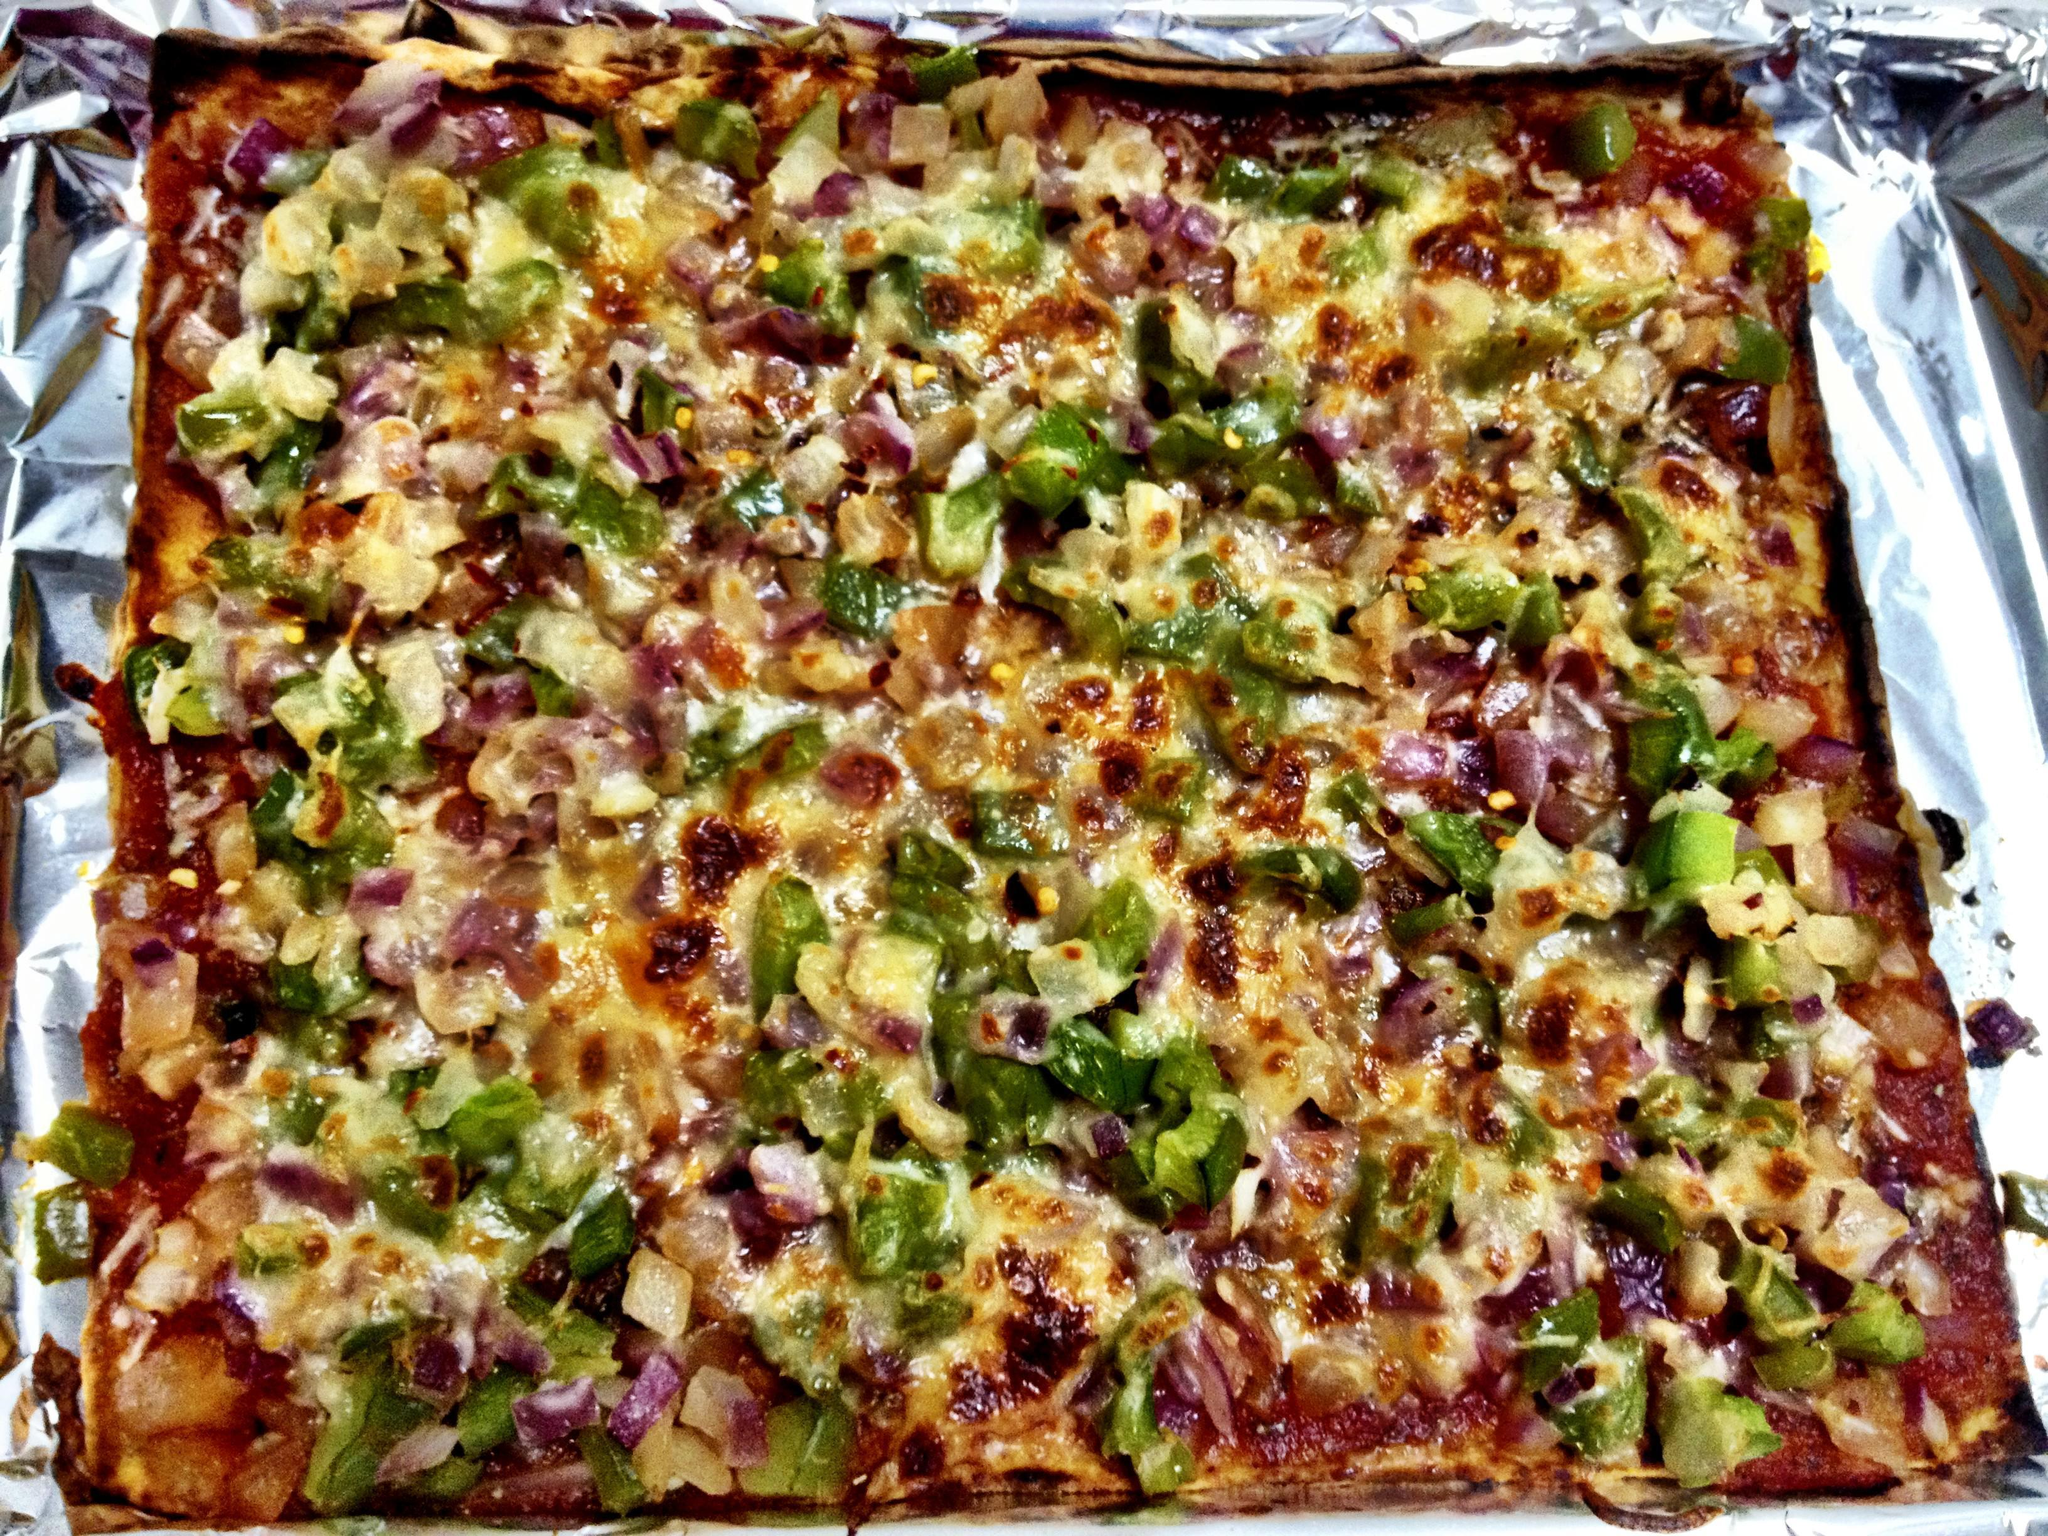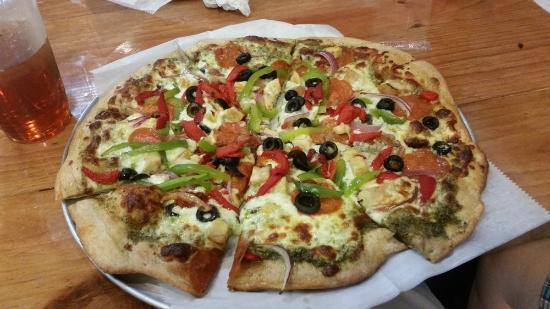The first image is the image on the left, the second image is the image on the right. For the images shown, is this caption "There is one round pizza in each image." true? Answer yes or no. No. The first image is the image on the left, the second image is the image on the right. Given the left and right images, does the statement "The left image features an uncut square pizza, and the right image contains at least part of a sliced round pizza." hold true? Answer yes or no. Yes. 